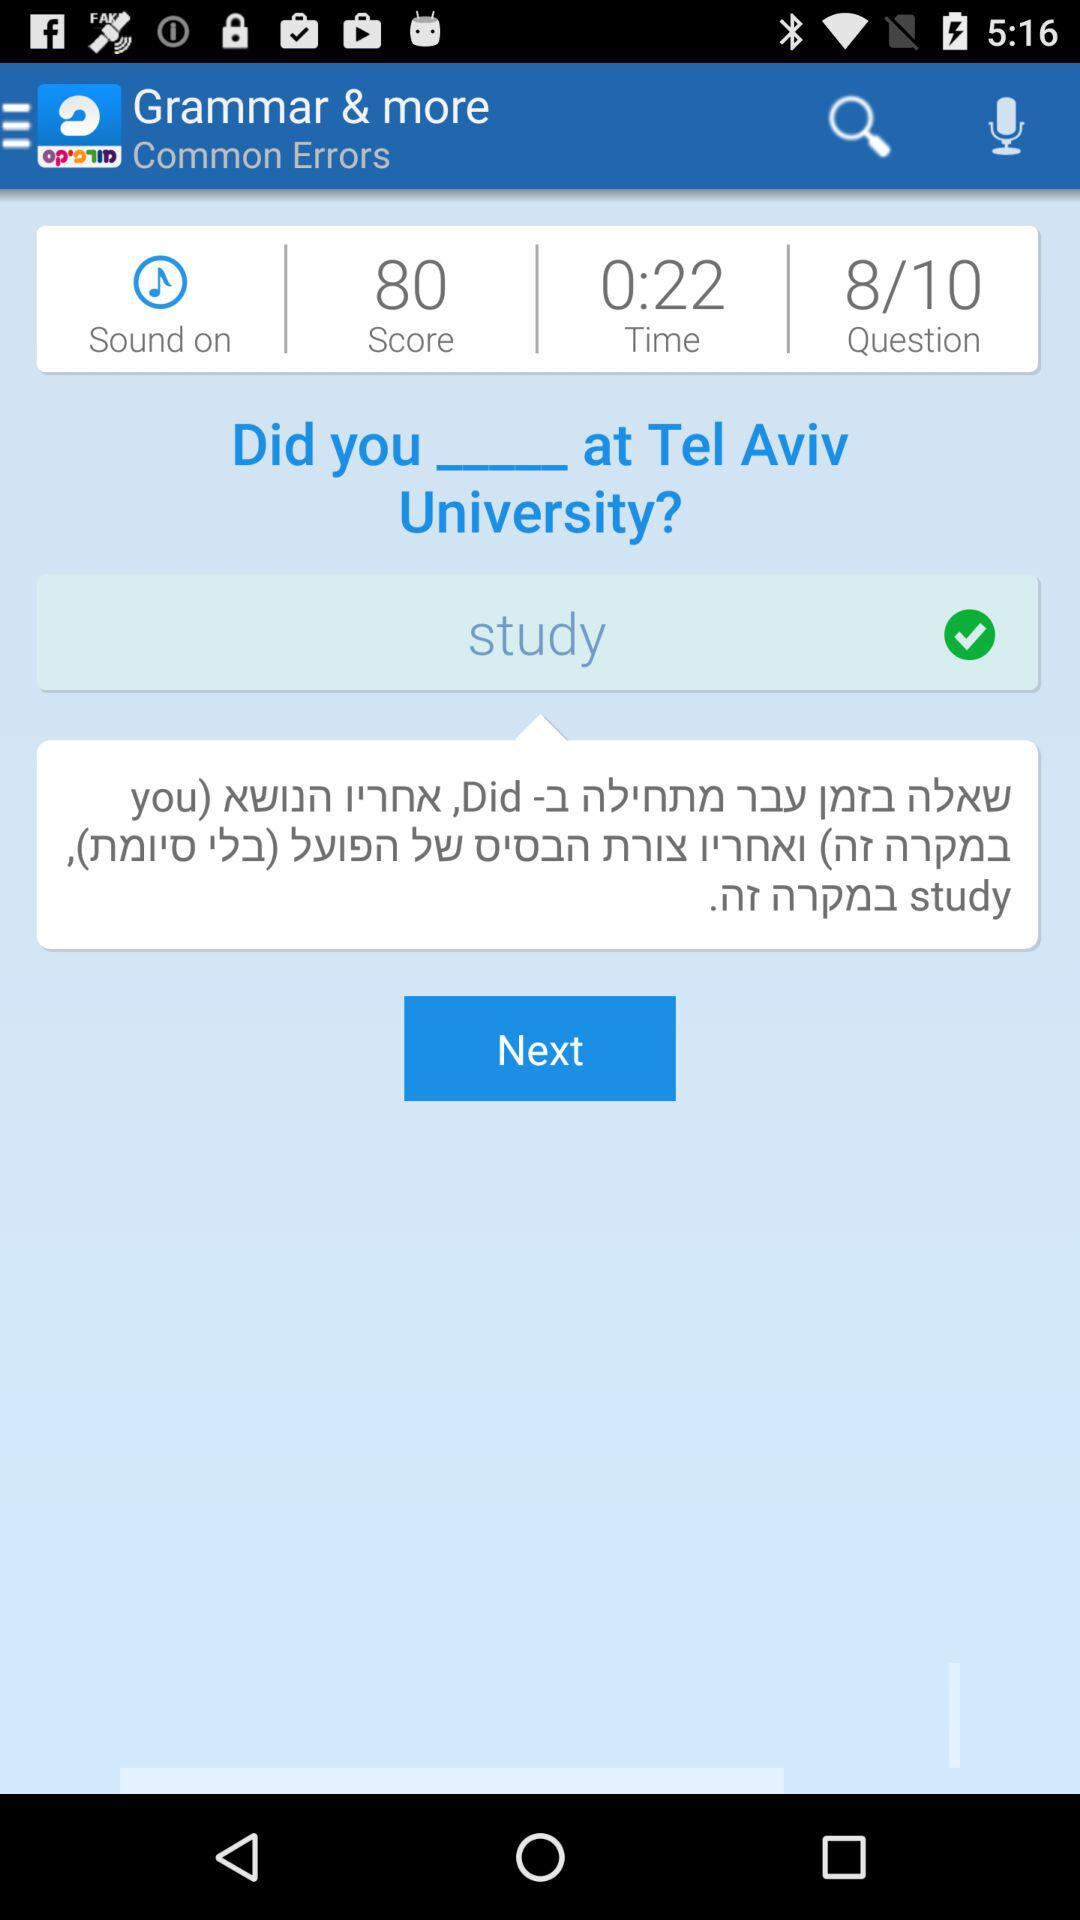What is the name of the application? The name of the application is "Morfix - English to Hebrew Tra". 